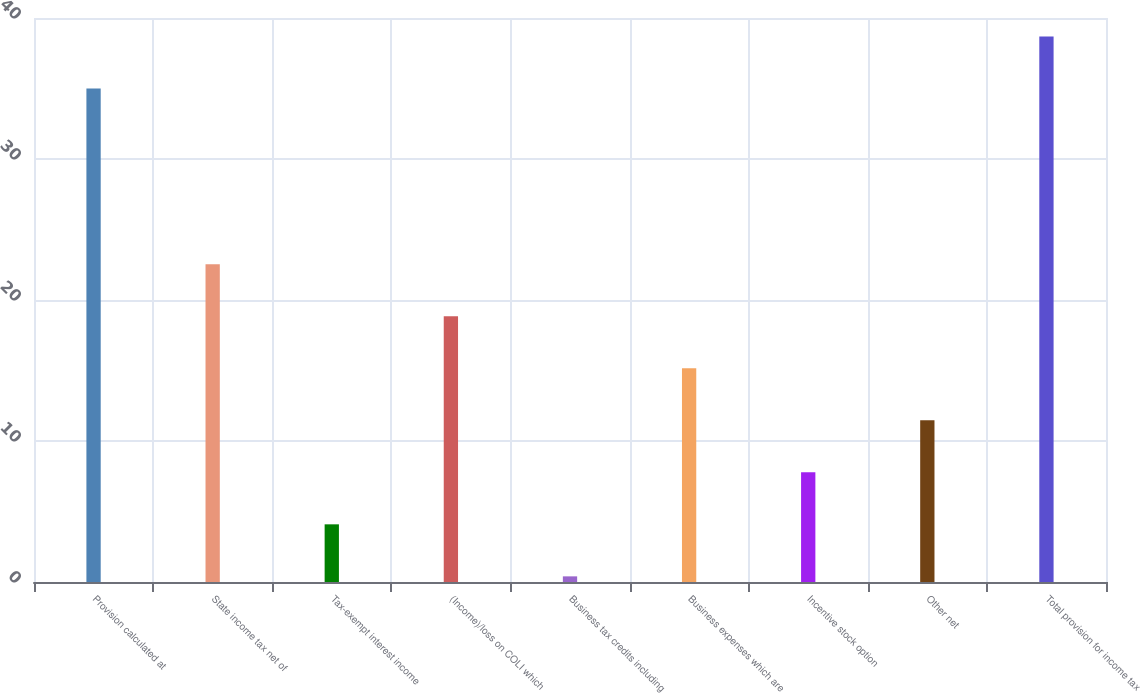<chart> <loc_0><loc_0><loc_500><loc_500><bar_chart><fcel>Provision calculated at<fcel>State income tax net of<fcel>Tax-exempt interest income<fcel>(Income)/loss on COLI which<fcel>Business tax credits including<fcel>Business expenses which are<fcel>Incentive stock option<fcel>Other net<fcel>Total provision for income tax<nl><fcel>35<fcel>22.54<fcel>4.09<fcel>18.85<fcel>0.4<fcel>15.16<fcel>7.78<fcel>11.47<fcel>38.69<nl></chart> 